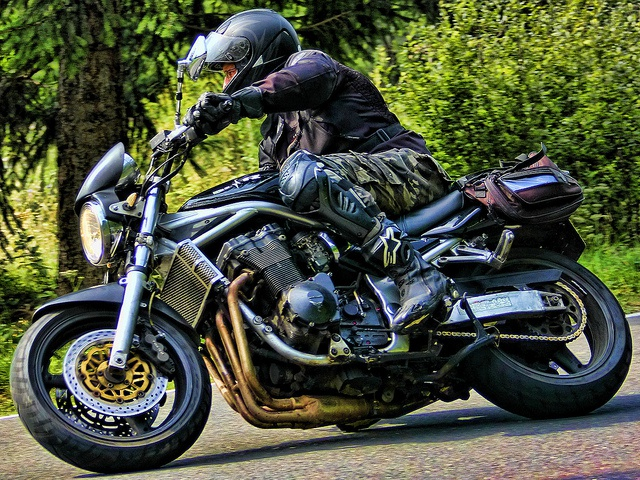Describe the objects in this image and their specific colors. I can see motorcycle in black, gray, white, and navy tones and people in black, gray, darkgray, and navy tones in this image. 